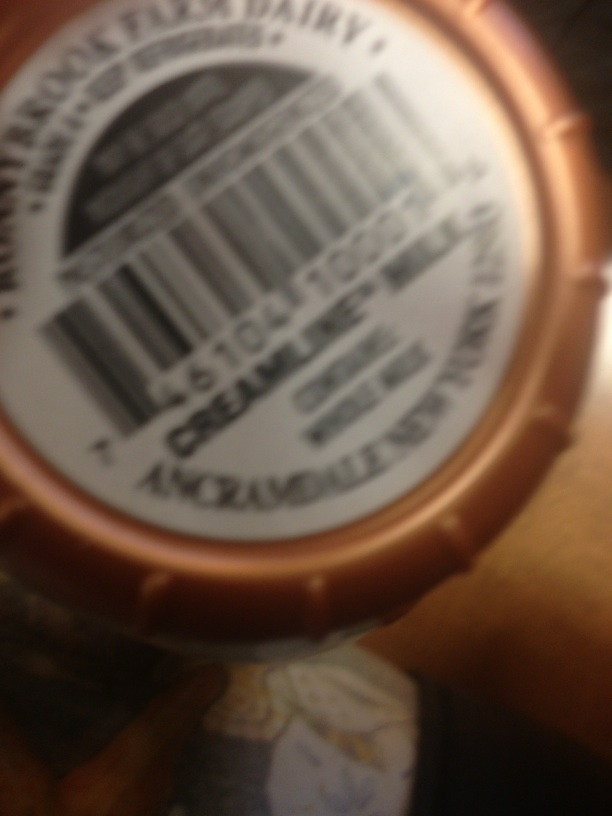Can you describe any visible details from the label in the image? Despite the blurriness of the image, there seems to be a circular logo or stamp, possibly indicating a brand or certification mark, though the specific details are not readable. Is there anything else discernible that might indicate what the label is for? The details are largely obscured, but it seems to be a label possibly related to food or drink given its shape and design typical of product labels in these categories. 